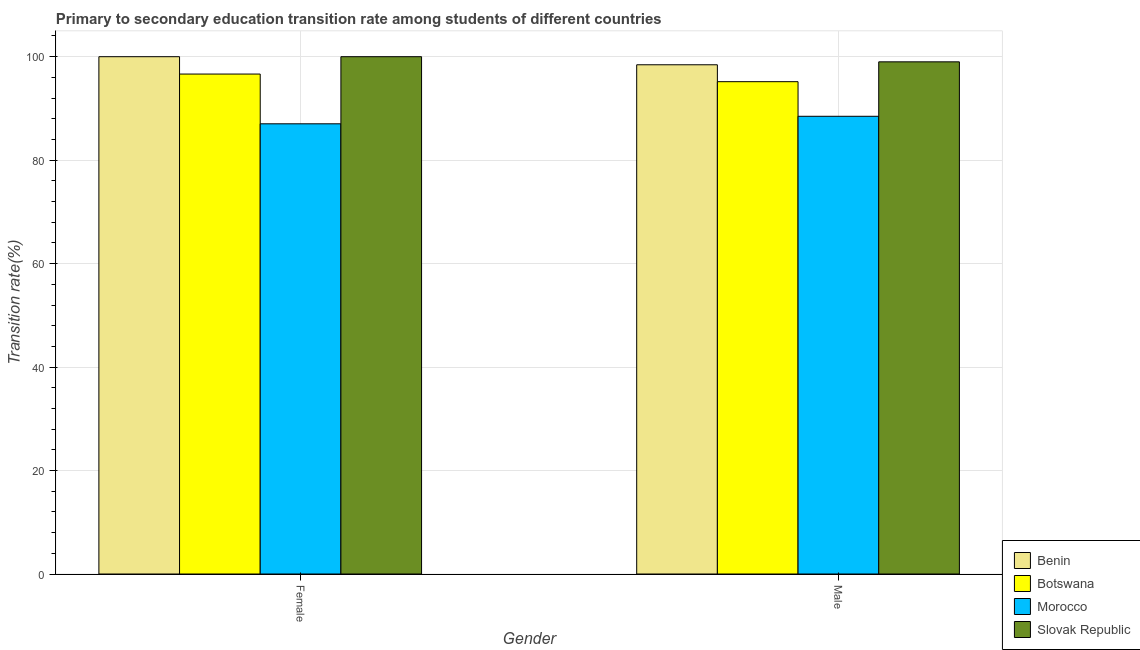How many groups of bars are there?
Ensure brevity in your answer.  2. Are the number of bars per tick equal to the number of legend labels?
Your answer should be very brief. Yes. Are the number of bars on each tick of the X-axis equal?
Offer a terse response. Yes. How many bars are there on the 2nd tick from the left?
Your answer should be compact. 4. How many bars are there on the 1st tick from the right?
Provide a succinct answer. 4. What is the label of the 2nd group of bars from the left?
Offer a terse response. Male. Across all countries, what is the minimum transition rate among male students?
Your response must be concise. 88.48. In which country was the transition rate among female students maximum?
Your response must be concise. Benin. In which country was the transition rate among female students minimum?
Ensure brevity in your answer.  Morocco. What is the total transition rate among male students in the graph?
Offer a terse response. 381.09. What is the difference between the transition rate among male students in Slovak Republic and that in Botswana?
Your response must be concise. 3.84. What is the difference between the transition rate among male students in Slovak Republic and the transition rate among female students in Benin?
Offer a terse response. -1. What is the average transition rate among male students per country?
Provide a short and direct response. 95.27. What is the difference between the transition rate among female students and transition rate among male students in Morocco?
Keep it short and to the point. -1.45. In how many countries, is the transition rate among female students greater than 24 %?
Keep it short and to the point. 4. What is the ratio of the transition rate among male students in Morocco to that in Botswana?
Offer a terse response. 0.93. Is the transition rate among male students in Botswana less than that in Slovak Republic?
Ensure brevity in your answer.  Yes. In how many countries, is the transition rate among male students greater than the average transition rate among male students taken over all countries?
Offer a very short reply. 2. What does the 2nd bar from the left in Female represents?
Your answer should be very brief. Botswana. What does the 2nd bar from the right in Male represents?
Your answer should be compact. Morocco. How many bars are there?
Your answer should be compact. 8. Are all the bars in the graph horizontal?
Give a very brief answer. No. What is the difference between two consecutive major ticks on the Y-axis?
Provide a succinct answer. 20. Does the graph contain any zero values?
Your answer should be very brief. No. Where does the legend appear in the graph?
Give a very brief answer. Bottom right. How are the legend labels stacked?
Your answer should be very brief. Vertical. What is the title of the graph?
Your answer should be compact. Primary to secondary education transition rate among students of different countries. Does "Solomon Islands" appear as one of the legend labels in the graph?
Provide a short and direct response. No. What is the label or title of the X-axis?
Ensure brevity in your answer.  Gender. What is the label or title of the Y-axis?
Make the answer very short. Transition rate(%). What is the Transition rate(%) in Benin in Female?
Offer a terse response. 100. What is the Transition rate(%) of Botswana in Female?
Provide a succinct answer. 96.64. What is the Transition rate(%) of Morocco in Female?
Offer a very short reply. 87.03. What is the Transition rate(%) in Benin in Male?
Keep it short and to the point. 98.44. What is the Transition rate(%) of Botswana in Male?
Offer a terse response. 95.17. What is the Transition rate(%) of Morocco in Male?
Offer a very short reply. 88.48. What is the Transition rate(%) in Slovak Republic in Male?
Offer a terse response. 99. Across all Gender, what is the maximum Transition rate(%) in Benin?
Your response must be concise. 100. Across all Gender, what is the maximum Transition rate(%) in Botswana?
Your answer should be compact. 96.64. Across all Gender, what is the maximum Transition rate(%) in Morocco?
Your answer should be compact. 88.48. Across all Gender, what is the maximum Transition rate(%) in Slovak Republic?
Provide a succinct answer. 100. Across all Gender, what is the minimum Transition rate(%) in Benin?
Provide a succinct answer. 98.44. Across all Gender, what is the minimum Transition rate(%) of Botswana?
Make the answer very short. 95.17. Across all Gender, what is the minimum Transition rate(%) in Morocco?
Your answer should be very brief. 87.03. Across all Gender, what is the minimum Transition rate(%) of Slovak Republic?
Your answer should be compact. 99. What is the total Transition rate(%) of Benin in the graph?
Your response must be concise. 198.44. What is the total Transition rate(%) in Botswana in the graph?
Keep it short and to the point. 191.81. What is the total Transition rate(%) in Morocco in the graph?
Keep it short and to the point. 175.51. What is the total Transition rate(%) in Slovak Republic in the graph?
Offer a very short reply. 199. What is the difference between the Transition rate(%) of Benin in Female and that in Male?
Your answer should be compact. 1.56. What is the difference between the Transition rate(%) of Botswana in Female and that in Male?
Offer a terse response. 1.47. What is the difference between the Transition rate(%) in Morocco in Female and that in Male?
Provide a succinct answer. -1.45. What is the difference between the Transition rate(%) of Slovak Republic in Female and that in Male?
Offer a very short reply. 1. What is the difference between the Transition rate(%) of Benin in Female and the Transition rate(%) of Botswana in Male?
Make the answer very short. 4.83. What is the difference between the Transition rate(%) in Benin in Female and the Transition rate(%) in Morocco in Male?
Offer a terse response. 11.52. What is the difference between the Transition rate(%) in Botswana in Female and the Transition rate(%) in Morocco in Male?
Make the answer very short. 8.16. What is the difference between the Transition rate(%) in Botswana in Female and the Transition rate(%) in Slovak Republic in Male?
Offer a very short reply. -2.36. What is the difference between the Transition rate(%) of Morocco in Female and the Transition rate(%) of Slovak Republic in Male?
Your response must be concise. -11.98. What is the average Transition rate(%) of Benin per Gender?
Your answer should be compact. 99.22. What is the average Transition rate(%) of Botswana per Gender?
Provide a short and direct response. 95.91. What is the average Transition rate(%) of Morocco per Gender?
Your answer should be compact. 87.75. What is the average Transition rate(%) in Slovak Republic per Gender?
Keep it short and to the point. 99.5. What is the difference between the Transition rate(%) in Benin and Transition rate(%) in Botswana in Female?
Provide a short and direct response. 3.36. What is the difference between the Transition rate(%) in Benin and Transition rate(%) in Morocco in Female?
Make the answer very short. 12.97. What is the difference between the Transition rate(%) in Botswana and Transition rate(%) in Morocco in Female?
Ensure brevity in your answer.  9.62. What is the difference between the Transition rate(%) in Botswana and Transition rate(%) in Slovak Republic in Female?
Your response must be concise. -3.36. What is the difference between the Transition rate(%) in Morocco and Transition rate(%) in Slovak Republic in Female?
Keep it short and to the point. -12.97. What is the difference between the Transition rate(%) of Benin and Transition rate(%) of Botswana in Male?
Offer a terse response. 3.27. What is the difference between the Transition rate(%) in Benin and Transition rate(%) in Morocco in Male?
Your answer should be very brief. 9.96. What is the difference between the Transition rate(%) of Benin and Transition rate(%) of Slovak Republic in Male?
Provide a succinct answer. -0.57. What is the difference between the Transition rate(%) in Botswana and Transition rate(%) in Morocco in Male?
Make the answer very short. 6.69. What is the difference between the Transition rate(%) of Botswana and Transition rate(%) of Slovak Republic in Male?
Your answer should be compact. -3.84. What is the difference between the Transition rate(%) of Morocco and Transition rate(%) of Slovak Republic in Male?
Make the answer very short. -10.52. What is the ratio of the Transition rate(%) of Benin in Female to that in Male?
Offer a terse response. 1.02. What is the ratio of the Transition rate(%) in Botswana in Female to that in Male?
Your answer should be compact. 1.02. What is the ratio of the Transition rate(%) in Morocco in Female to that in Male?
Keep it short and to the point. 0.98. What is the difference between the highest and the second highest Transition rate(%) in Benin?
Your answer should be very brief. 1.56. What is the difference between the highest and the second highest Transition rate(%) of Botswana?
Ensure brevity in your answer.  1.47. What is the difference between the highest and the second highest Transition rate(%) of Morocco?
Ensure brevity in your answer.  1.45. What is the difference between the highest and the second highest Transition rate(%) of Slovak Republic?
Provide a short and direct response. 1. What is the difference between the highest and the lowest Transition rate(%) of Benin?
Keep it short and to the point. 1.56. What is the difference between the highest and the lowest Transition rate(%) of Botswana?
Keep it short and to the point. 1.47. What is the difference between the highest and the lowest Transition rate(%) of Morocco?
Offer a terse response. 1.45. 